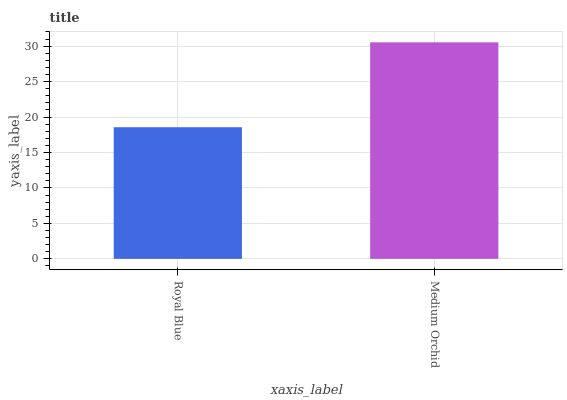Is Royal Blue the minimum?
Answer yes or no. Yes. Is Medium Orchid the maximum?
Answer yes or no. Yes. Is Medium Orchid the minimum?
Answer yes or no. No. Is Medium Orchid greater than Royal Blue?
Answer yes or no. Yes. Is Royal Blue less than Medium Orchid?
Answer yes or no. Yes. Is Royal Blue greater than Medium Orchid?
Answer yes or no. No. Is Medium Orchid less than Royal Blue?
Answer yes or no. No. Is Medium Orchid the high median?
Answer yes or no. Yes. Is Royal Blue the low median?
Answer yes or no. Yes. Is Royal Blue the high median?
Answer yes or no. No. Is Medium Orchid the low median?
Answer yes or no. No. 